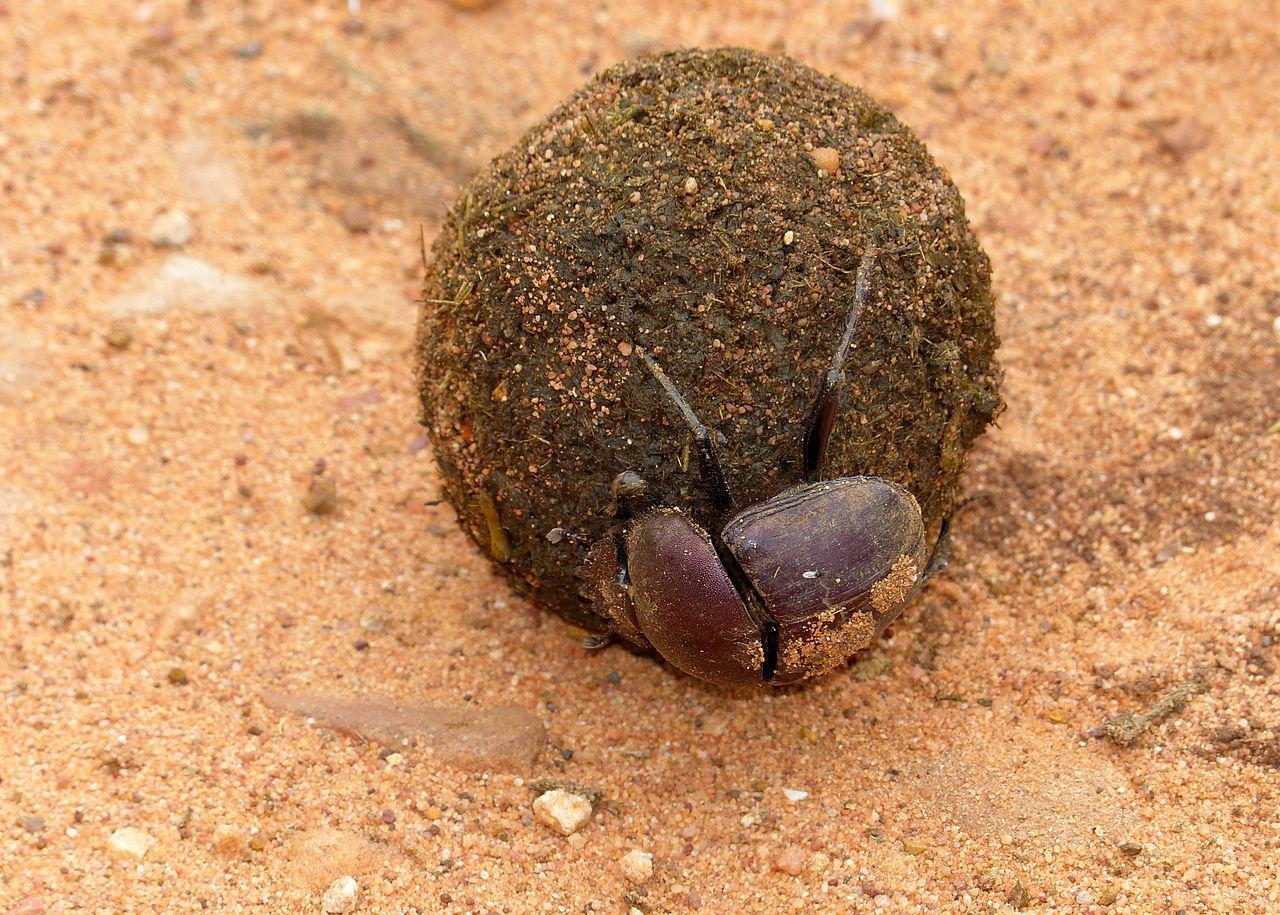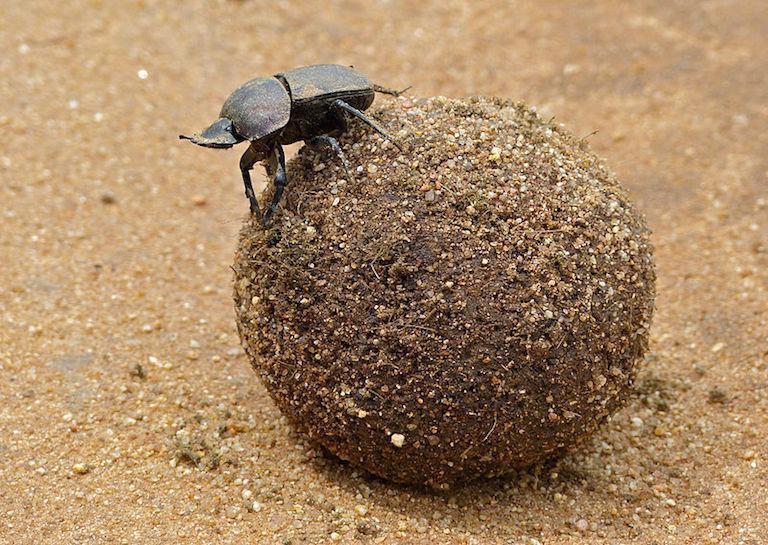The first image is the image on the left, the second image is the image on the right. For the images shown, is this caption "Each image shows a beetle with a dungball that is bigger than the beetle." true? Answer yes or no. Yes. The first image is the image on the left, the second image is the image on the right. Given the left and right images, does the statement "There is a beetle on top of a dung ball." hold true? Answer yes or no. Yes. 